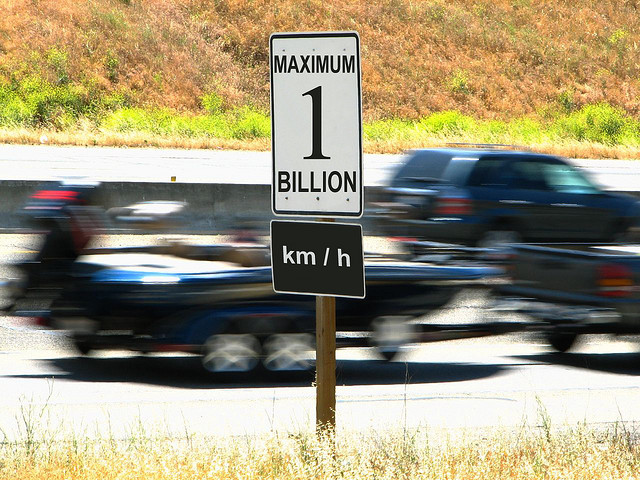Is the texture on the road sign retained?
A. Blurry
B. Lost
C. Yes
D. Smudged
Answer with the option's letter from the given choices directly.
 C. 